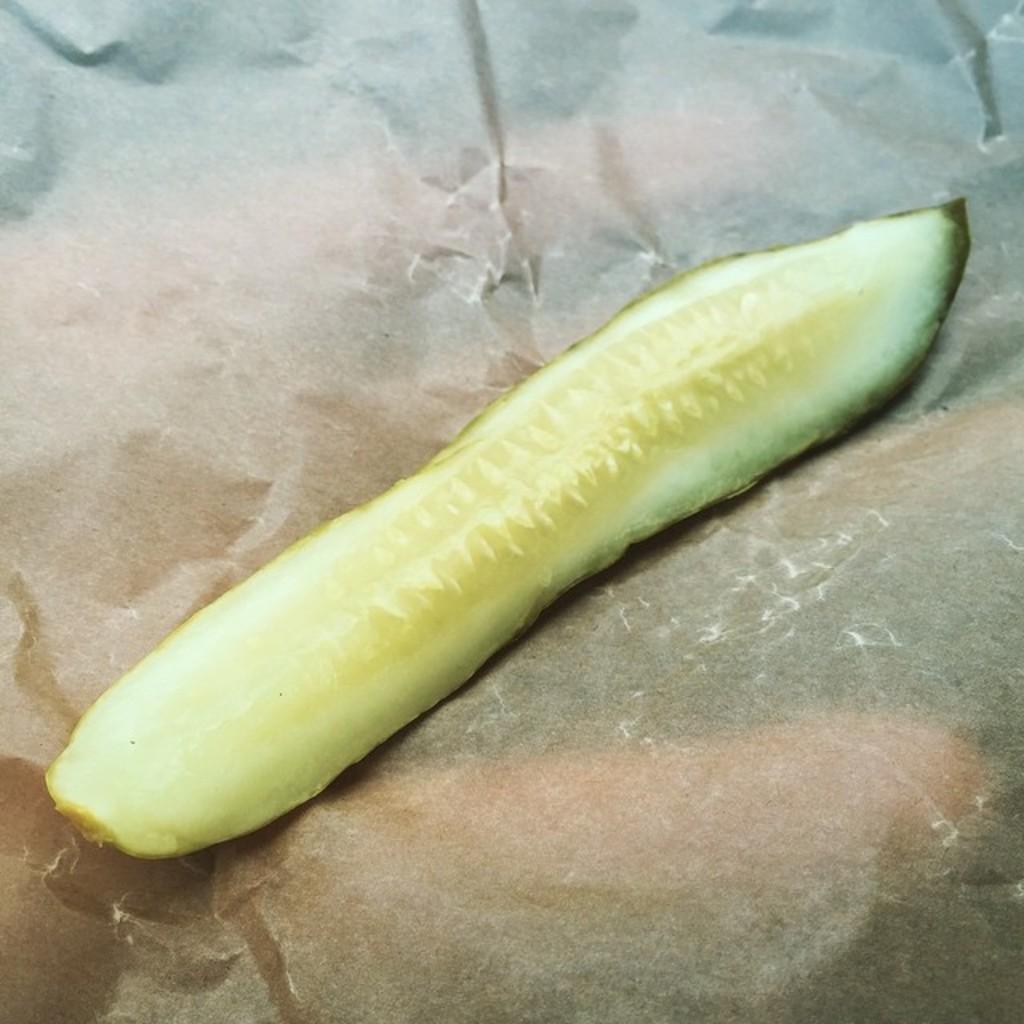Describe this image in one or two sentences. In this image there is a peeled cucumber. 